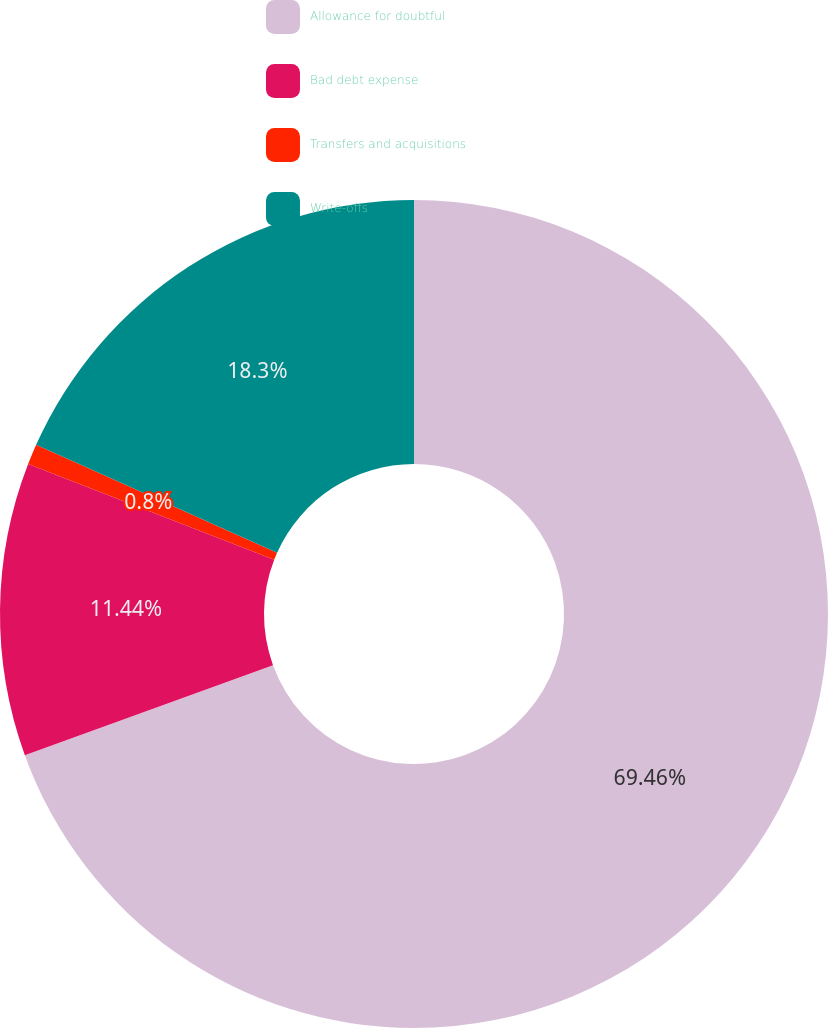Convert chart to OTSL. <chart><loc_0><loc_0><loc_500><loc_500><pie_chart><fcel>Allowance for doubtful<fcel>Bad debt expense<fcel>Transfers and acquisitions<fcel>Write-offs<nl><fcel>69.46%<fcel>11.44%<fcel>0.8%<fcel>18.3%<nl></chart> 